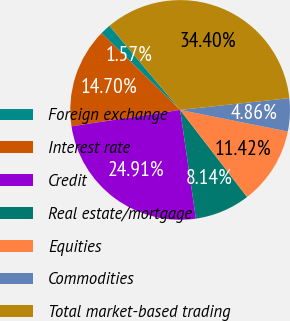Convert chart. <chart><loc_0><loc_0><loc_500><loc_500><pie_chart><fcel>Foreign exchange<fcel>Interest rate<fcel>Credit<fcel>Real estate/mortgage<fcel>Equities<fcel>Commodities<fcel>Total market-based trading<nl><fcel>1.57%<fcel>14.7%<fcel>24.91%<fcel>8.14%<fcel>11.42%<fcel>4.86%<fcel>34.4%<nl></chart> 